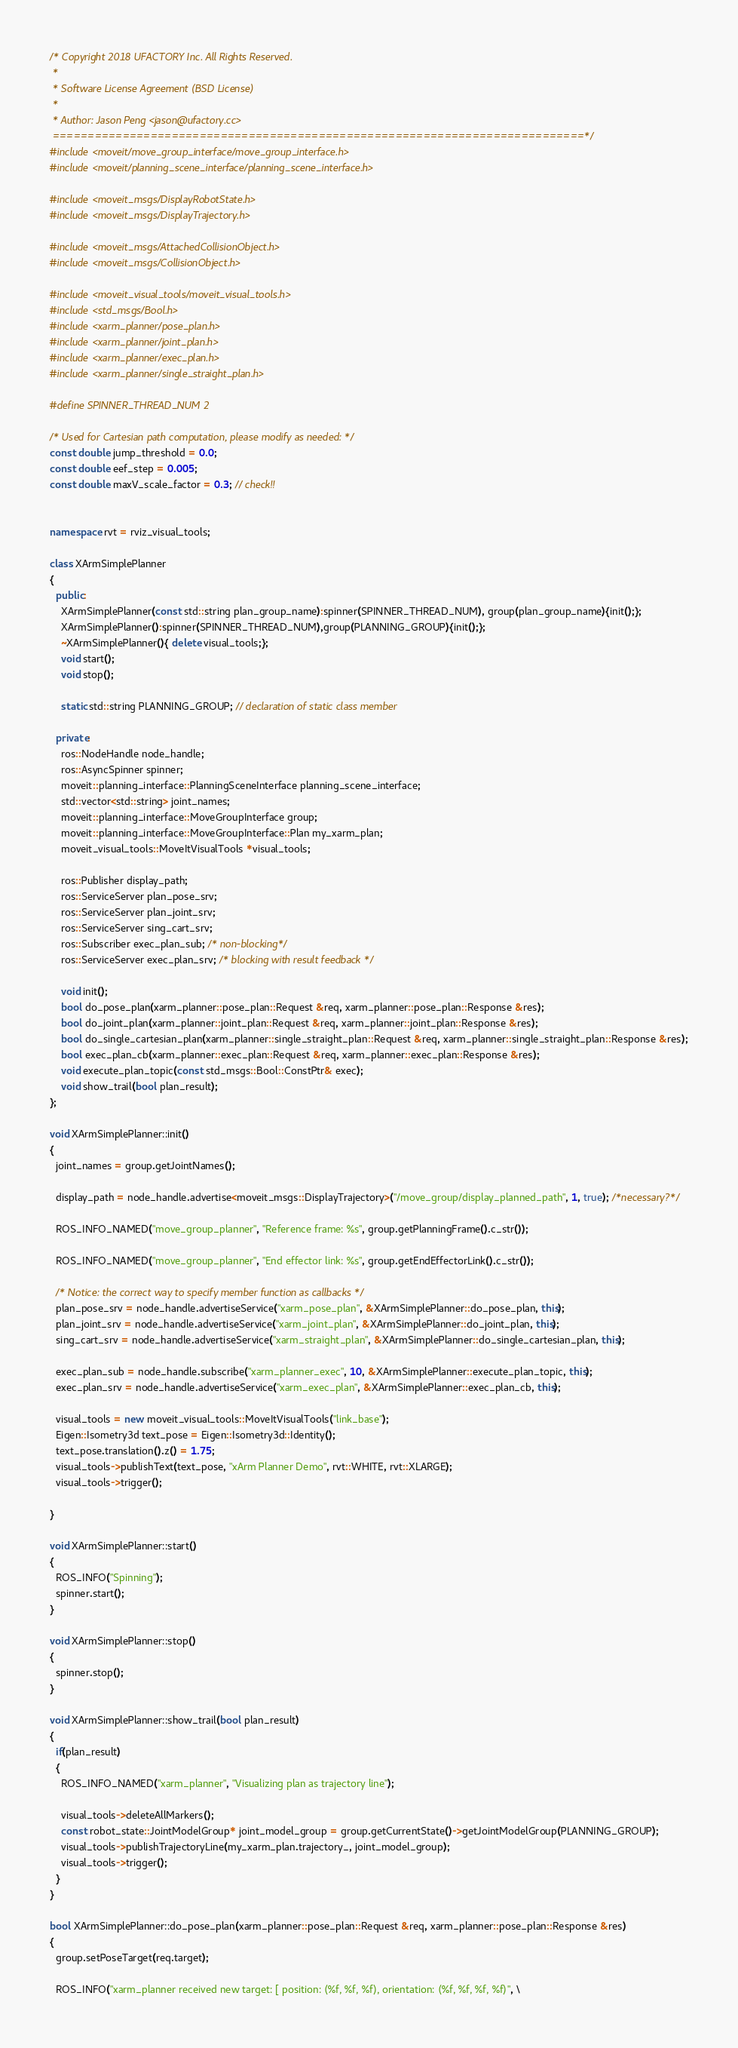<code> <loc_0><loc_0><loc_500><loc_500><_C++_>/* Copyright 2018 UFACTORY Inc. All Rights Reserved.
 *
 * Software License Agreement (BSD License)
 *
 * Author: Jason Peng <jason@ufactory.cc>
 ============================================================================*/
#include <moveit/move_group_interface/move_group_interface.h>
#include <moveit/planning_scene_interface/planning_scene_interface.h>

#include <moveit_msgs/DisplayRobotState.h>
#include <moveit_msgs/DisplayTrajectory.h>

#include <moveit_msgs/AttachedCollisionObject.h>
#include <moveit_msgs/CollisionObject.h>

#include <moveit_visual_tools/moveit_visual_tools.h>
#include <std_msgs/Bool.h>
#include <xarm_planner/pose_plan.h>
#include <xarm_planner/joint_plan.h>
#include <xarm_planner/exec_plan.h>
#include <xarm_planner/single_straight_plan.h>

#define SPINNER_THREAD_NUM 2

/* Used for Cartesian path computation, please modify as needed: */
const double jump_threshold = 0.0;
const double eef_step = 0.005;
const double maxV_scale_factor = 0.3; // check!!


namespace rvt = rviz_visual_tools;

class XArmSimplePlanner
{
  public:
    XArmSimplePlanner(const std::string plan_group_name):spinner(SPINNER_THREAD_NUM), group(plan_group_name){init();};
    XArmSimplePlanner():spinner(SPINNER_THREAD_NUM),group(PLANNING_GROUP){init();};
    ~XArmSimplePlanner(){ delete visual_tools;};
    void start();
    void stop();

    static std::string PLANNING_GROUP; // declaration of static class member

  private:
    ros::NodeHandle node_handle;
    ros::AsyncSpinner spinner;
    moveit::planning_interface::PlanningSceneInterface planning_scene_interface;
    std::vector<std::string> joint_names;
    moveit::planning_interface::MoveGroupInterface group;
    moveit::planning_interface::MoveGroupInterface::Plan my_xarm_plan;
    moveit_visual_tools::MoveItVisualTools *visual_tools;

    ros::Publisher display_path;
    ros::ServiceServer plan_pose_srv;
    ros::ServiceServer plan_joint_srv;
    ros::ServiceServer sing_cart_srv;
    ros::Subscriber exec_plan_sub; /* non-blocking*/
    ros::ServiceServer exec_plan_srv; /* blocking with result feedback */

    void init();
    bool do_pose_plan(xarm_planner::pose_plan::Request &req, xarm_planner::pose_plan::Response &res);
    bool do_joint_plan(xarm_planner::joint_plan::Request &req, xarm_planner::joint_plan::Response &res);
    bool do_single_cartesian_plan(xarm_planner::single_straight_plan::Request &req, xarm_planner::single_straight_plan::Response &res);
    bool exec_plan_cb(xarm_planner::exec_plan::Request &req, xarm_planner::exec_plan::Response &res);
    void execute_plan_topic(const std_msgs::Bool::ConstPtr& exec);
    void show_trail(bool plan_result);
};

void XArmSimplePlanner::init()
{
  joint_names = group.getJointNames();

  display_path = node_handle.advertise<moveit_msgs::DisplayTrajectory>("/move_group/display_planned_path", 1, true); /*necessary?*/

  ROS_INFO_NAMED("move_group_planner", "Reference frame: %s", group.getPlanningFrame().c_str());

  ROS_INFO_NAMED("move_group_planner", "End effector link: %s", group.getEndEffectorLink().c_str());

  /* Notice: the correct way to specify member function as callbacks */
  plan_pose_srv = node_handle.advertiseService("xarm_pose_plan", &XArmSimplePlanner::do_pose_plan, this);
  plan_joint_srv = node_handle.advertiseService("xarm_joint_plan", &XArmSimplePlanner::do_joint_plan, this);
  sing_cart_srv = node_handle.advertiseService("xarm_straight_plan", &XArmSimplePlanner::do_single_cartesian_plan, this);

  exec_plan_sub = node_handle.subscribe("xarm_planner_exec", 10, &XArmSimplePlanner::execute_plan_topic, this);
  exec_plan_srv = node_handle.advertiseService("xarm_exec_plan", &XArmSimplePlanner::exec_plan_cb, this);

  visual_tools = new moveit_visual_tools::MoveItVisualTools("link_base");
  Eigen::Isometry3d text_pose = Eigen::Isometry3d::Identity();
  text_pose.translation().z() = 1.75;
  visual_tools->publishText(text_pose, "xArm Planner Demo", rvt::WHITE, rvt::XLARGE);
  visual_tools->trigger();

}

void XArmSimplePlanner::start()
{
  ROS_INFO("Spinning");
  spinner.start();
}

void XArmSimplePlanner::stop()
{
  spinner.stop();
}

void XArmSimplePlanner::show_trail(bool plan_result)
{
  if(plan_result)
  {
    ROS_INFO_NAMED("xarm_planner", "Visualizing plan as trajectory line");
    
    visual_tools->deleteAllMarkers();
    const robot_state::JointModelGroup* joint_model_group = group.getCurrentState()->getJointModelGroup(PLANNING_GROUP);
    visual_tools->publishTrajectoryLine(my_xarm_plan.trajectory_, joint_model_group);
    visual_tools->trigger();
  }
}

bool XArmSimplePlanner::do_pose_plan(xarm_planner::pose_plan::Request &req, xarm_planner::pose_plan::Response &res)
{
  group.setPoseTarget(req.target);
  
  ROS_INFO("xarm_planner received new target: [ position: (%f, %f, %f), orientation: (%f, %f, %f, %f)", \</code> 